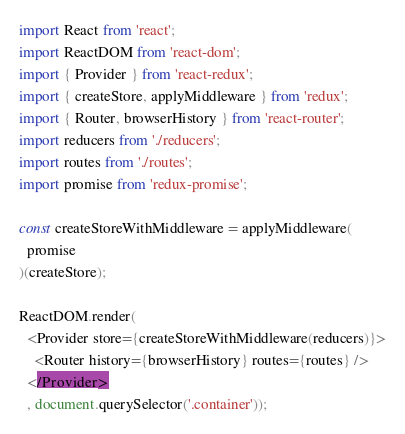<code> <loc_0><loc_0><loc_500><loc_500><_JavaScript_>import React from 'react';
import ReactDOM from 'react-dom';
import { Provider } from 'react-redux';
import { createStore, applyMiddleware } from 'redux';
import { Router, browserHistory } from 'react-router';
import reducers from './reducers';
import routes from './routes';
import promise from 'redux-promise';

const createStoreWithMiddleware = applyMiddleware(
  promise
)(createStore);

ReactDOM.render(
  <Provider store={createStoreWithMiddleware(reducers)}>
    <Router history={browserHistory} routes={routes} />
  </Provider>
  , document.querySelector('.container'));</code> 